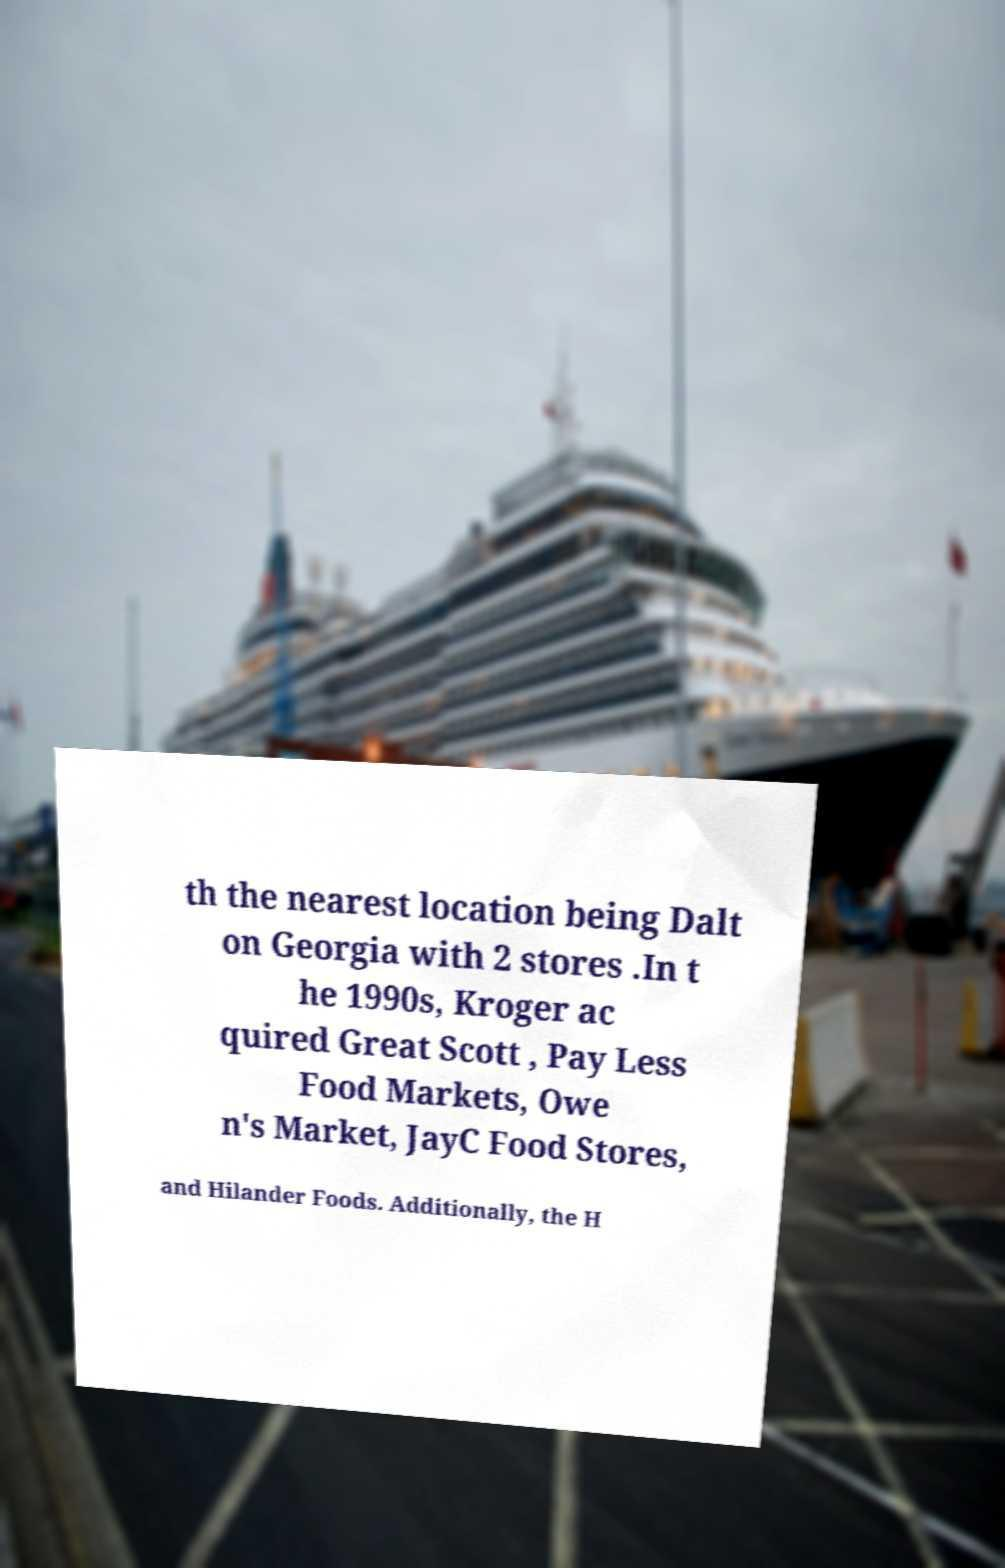What messages or text are displayed in this image? I need them in a readable, typed format. th the nearest location being Dalt on Georgia with 2 stores .In t he 1990s, Kroger ac quired Great Scott , Pay Less Food Markets, Owe n's Market, JayC Food Stores, and Hilander Foods. Additionally, the H 